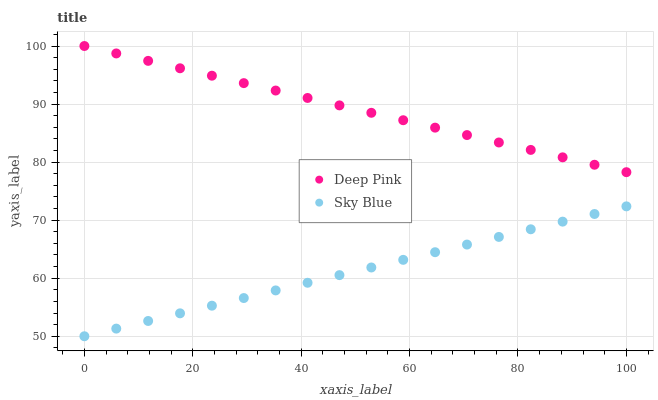Does Sky Blue have the minimum area under the curve?
Answer yes or no. Yes. Does Deep Pink have the maximum area under the curve?
Answer yes or no. Yes. Does Deep Pink have the minimum area under the curve?
Answer yes or no. No. Is Sky Blue the smoothest?
Answer yes or no. Yes. Is Deep Pink the roughest?
Answer yes or no. Yes. Is Deep Pink the smoothest?
Answer yes or no. No. Does Sky Blue have the lowest value?
Answer yes or no. Yes. Does Deep Pink have the lowest value?
Answer yes or no. No. Does Deep Pink have the highest value?
Answer yes or no. Yes. Is Sky Blue less than Deep Pink?
Answer yes or no. Yes. Is Deep Pink greater than Sky Blue?
Answer yes or no. Yes. Does Sky Blue intersect Deep Pink?
Answer yes or no. No. 